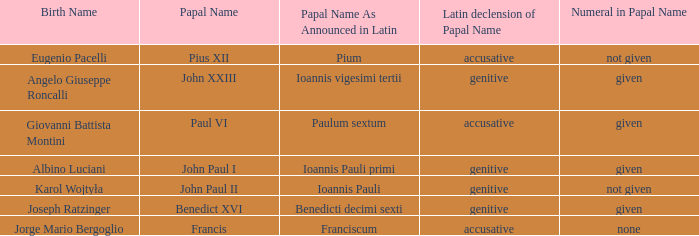What numeral is included for the pope with papal name in Latin of Ioannis Pauli? Not given. 